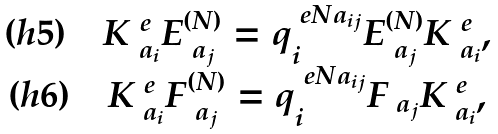<formula> <loc_0><loc_0><loc_500><loc_500>\begin{matrix} ( h 5 ) \quad K _ { \ a _ { i } } ^ { \ e } E _ { \ a _ { j } } ^ { ( N ) } = q _ { i } ^ { \ e N a _ { i j } } E _ { \ a _ { j } } ^ { ( N ) } K _ { \ a _ { i } } ^ { \ e } , \\ ( h 6 ) \quad K _ { \ a _ { i } } ^ { \ e } F _ { \ a _ { j } } ^ { ( N ) } = q _ { i } ^ { \ e N a _ { i j } } F _ { \ a _ { j } } K _ { \ a _ { i } } ^ { \ e } , \end{matrix}</formula> 